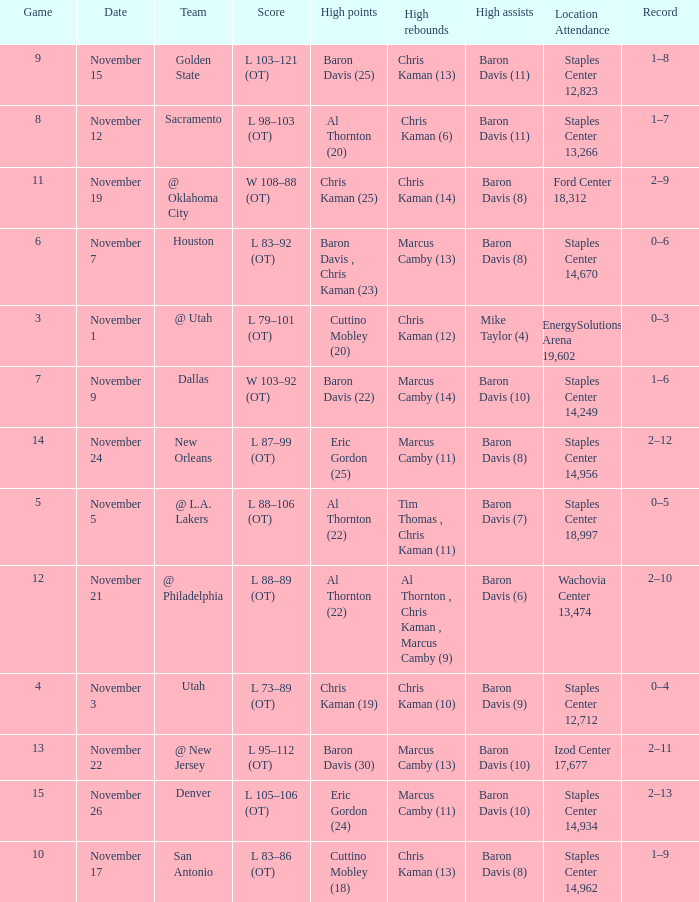Would you mind parsing the complete table? {'header': ['Game', 'Date', 'Team', 'Score', 'High points', 'High rebounds', 'High assists', 'Location Attendance', 'Record'], 'rows': [['9', 'November 15', 'Golden State', 'L 103–121 (OT)', 'Baron Davis (25)', 'Chris Kaman (13)', 'Baron Davis (11)', 'Staples Center 12,823', '1–8'], ['8', 'November 12', 'Sacramento', 'L 98–103 (OT)', 'Al Thornton (20)', 'Chris Kaman (6)', 'Baron Davis (11)', 'Staples Center 13,266', '1–7'], ['11', 'November 19', '@ Oklahoma City', 'W 108–88 (OT)', 'Chris Kaman (25)', 'Chris Kaman (14)', 'Baron Davis (8)', 'Ford Center 18,312', '2–9'], ['6', 'November 7', 'Houston', 'L 83–92 (OT)', 'Baron Davis , Chris Kaman (23)', 'Marcus Camby (13)', 'Baron Davis (8)', 'Staples Center 14,670', '0–6'], ['3', 'November 1', '@ Utah', 'L 79–101 (OT)', 'Cuttino Mobley (20)', 'Chris Kaman (12)', 'Mike Taylor (4)', 'EnergySolutions Arena 19,602', '0–3'], ['7', 'November 9', 'Dallas', 'W 103–92 (OT)', 'Baron Davis (22)', 'Marcus Camby (14)', 'Baron Davis (10)', 'Staples Center 14,249', '1–6'], ['14', 'November 24', 'New Orleans', 'L 87–99 (OT)', 'Eric Gordon (25)', 'Marcus Camby (11)', 'Baron Davis (8)', 'Staples Center 14,956', '2–12'], ['5', 'November 5', '@ L.A. Lakers', 'L 88–106 (OT)', 'Al Thornton (22)', 'Tim Thomas , Chris Kaman (11)', 'Baron Davis (7)', 'Staples Center 18,997', '0–5'], ['12', 'November 21', '@ Philadelphia', 'L 88–89 (OT)', 'Al Thornton (22)', 'Al Thornton , Chris Kaman , Marcus Camby (9)', 'Baron Davis (6)', 'Wachovia Center 13,474', '2–10'], ['4', 'November 3', 'Utah', 'L 73–89 (OT)', 'Chris Kaman (19)', 'Chris Kaman (10)', 'Baron Davis (9)', 'Staples Center 12,712', '0–4'], ['13', 'November 22', '@ New Jersey', 'L 95–112 (OT)', 'Baron Davis (30)', 'Marcus Camby (13)', 'Baron Davis (10)', 'Izod Center 17,677', '2–11'], ['15', 'November 26', 'Denver', 'L 105–106 (OT)', 'Eric Gordon (24)', 'Marcus Camby (11)', 'Baron Davis (10)', 'Staples Center 14,934', '2–13'], ['10', 'November 17', 'San Antonio', 'L 83–86 (OT)', 'Cuttino Mobley (18)', 'Chris Kaman (13)', 'Baron Davis (8)', 'Staples Center 14,962', '1–9']]} Name the high points for the date of november 24 Eric Gordon (25). 